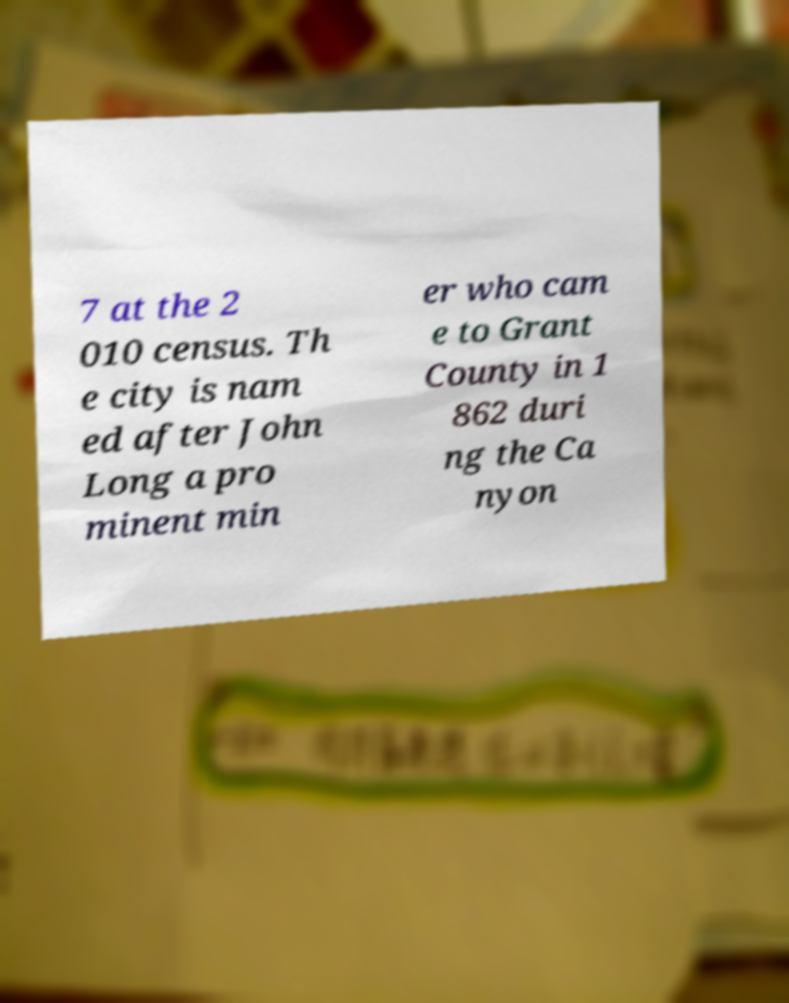Please read and relay the text visible in this image. What does it say? 7 at the 2 010 census. Th e city is nam ed after John Long a pro minent min er who cam e to Grant County in 1 862 duri ng the Ca nyon 